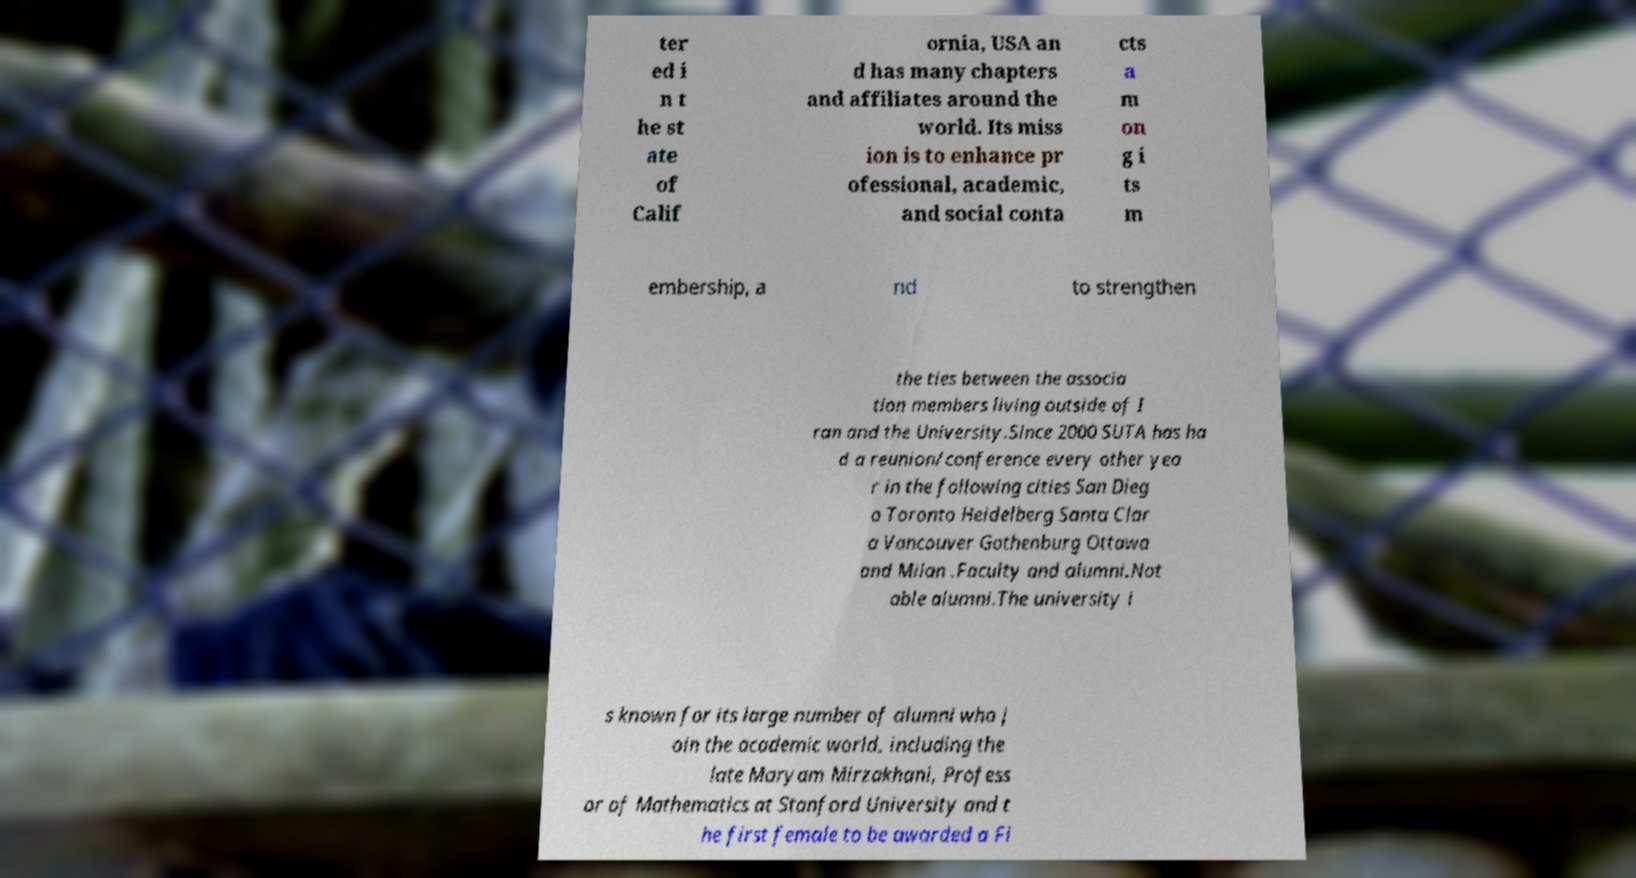Could you extract and type out the text from this image? ter ed i n t he st ate of Calif ornia, USA an d has many chapters and affiliates around the world. Its miss ion is to enhance pr ofessional, academic, and social conta cts a m on g i ts m embership, a nd to strengthen the ties between the associa tion members living outside of I ran and the University.Since 2000 SUTA has ha d a reunion/conference every other yea r in the following cities San Dieg o Toronto Heidelberg Santa Clar a Vancouver Gothenburg Ottawa and Milan .Faculty and alumni.Not able alumni.The university i s known for its large number of alumni who j oin the academic world, including the late Maryam Mirzakhani, Profess or of Mathematics at Stanford University and t he first female to be awarded a Fi 